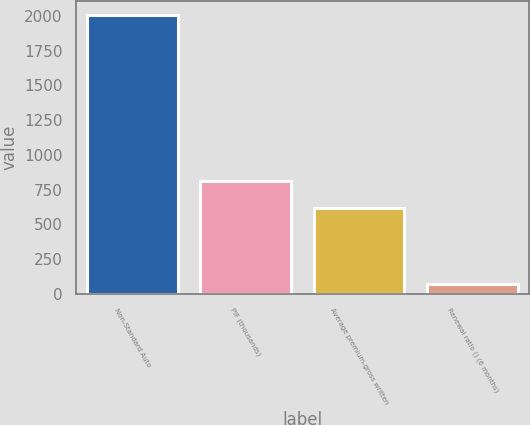Convert chart to OTSL. <chart><loc_0><loc_0><loc_500><loc_500><bar_chart><fcel>Non-Standard Auto<fcel>PIF (thousands)<fcel>Average premium-gross written<fcel>Renewal ratio () (6 months)<nl><fcel>2009<fcel>809.65<fcel>616<fcel>72.5<nl></chart> 